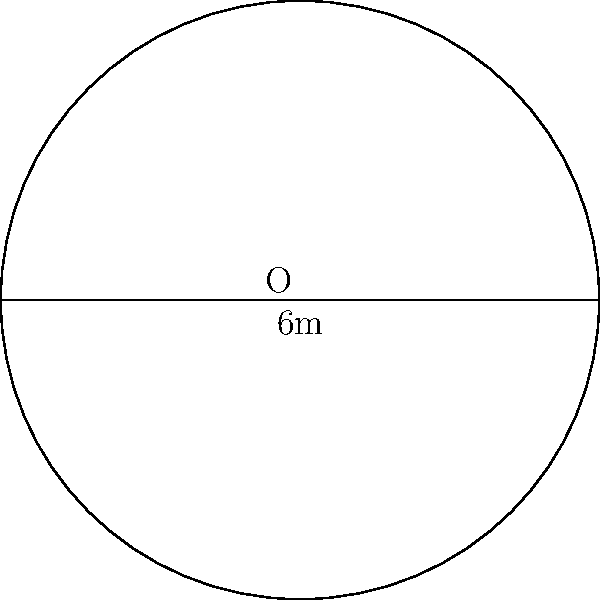In your favorite TV series, a character needs to install a circular satellite dish antenna to watch international shows. If the diameter of the antenna is 6 meters, what is the area of the dish in square meters? Round your answer to two decimal places. Let's solve this step-by-step:

1) We're given the diameter of the circular dish, which is 6 meters.

2) We need to find the radius. The radius is half of the diameter:
   $r = \frac{diameter}{2} = \frac{6}{2} = 3$ meters

3) The formula for the area of a circle is:
   $A = \pi r^2$

4) Let's substitute our radius value:
   $A = \pi (3)^2$

5) Simplify:
   $A = 9\pi$ square meters

6) Using 3.14159 as an approximation for $\pi$:
   $A \approx 9 \times 3.14159 = 28.27431$ square meters

7) Rounding to two decimal places:
   $A \approx 28.27$ square meters
Answer: 28.27 square meters 